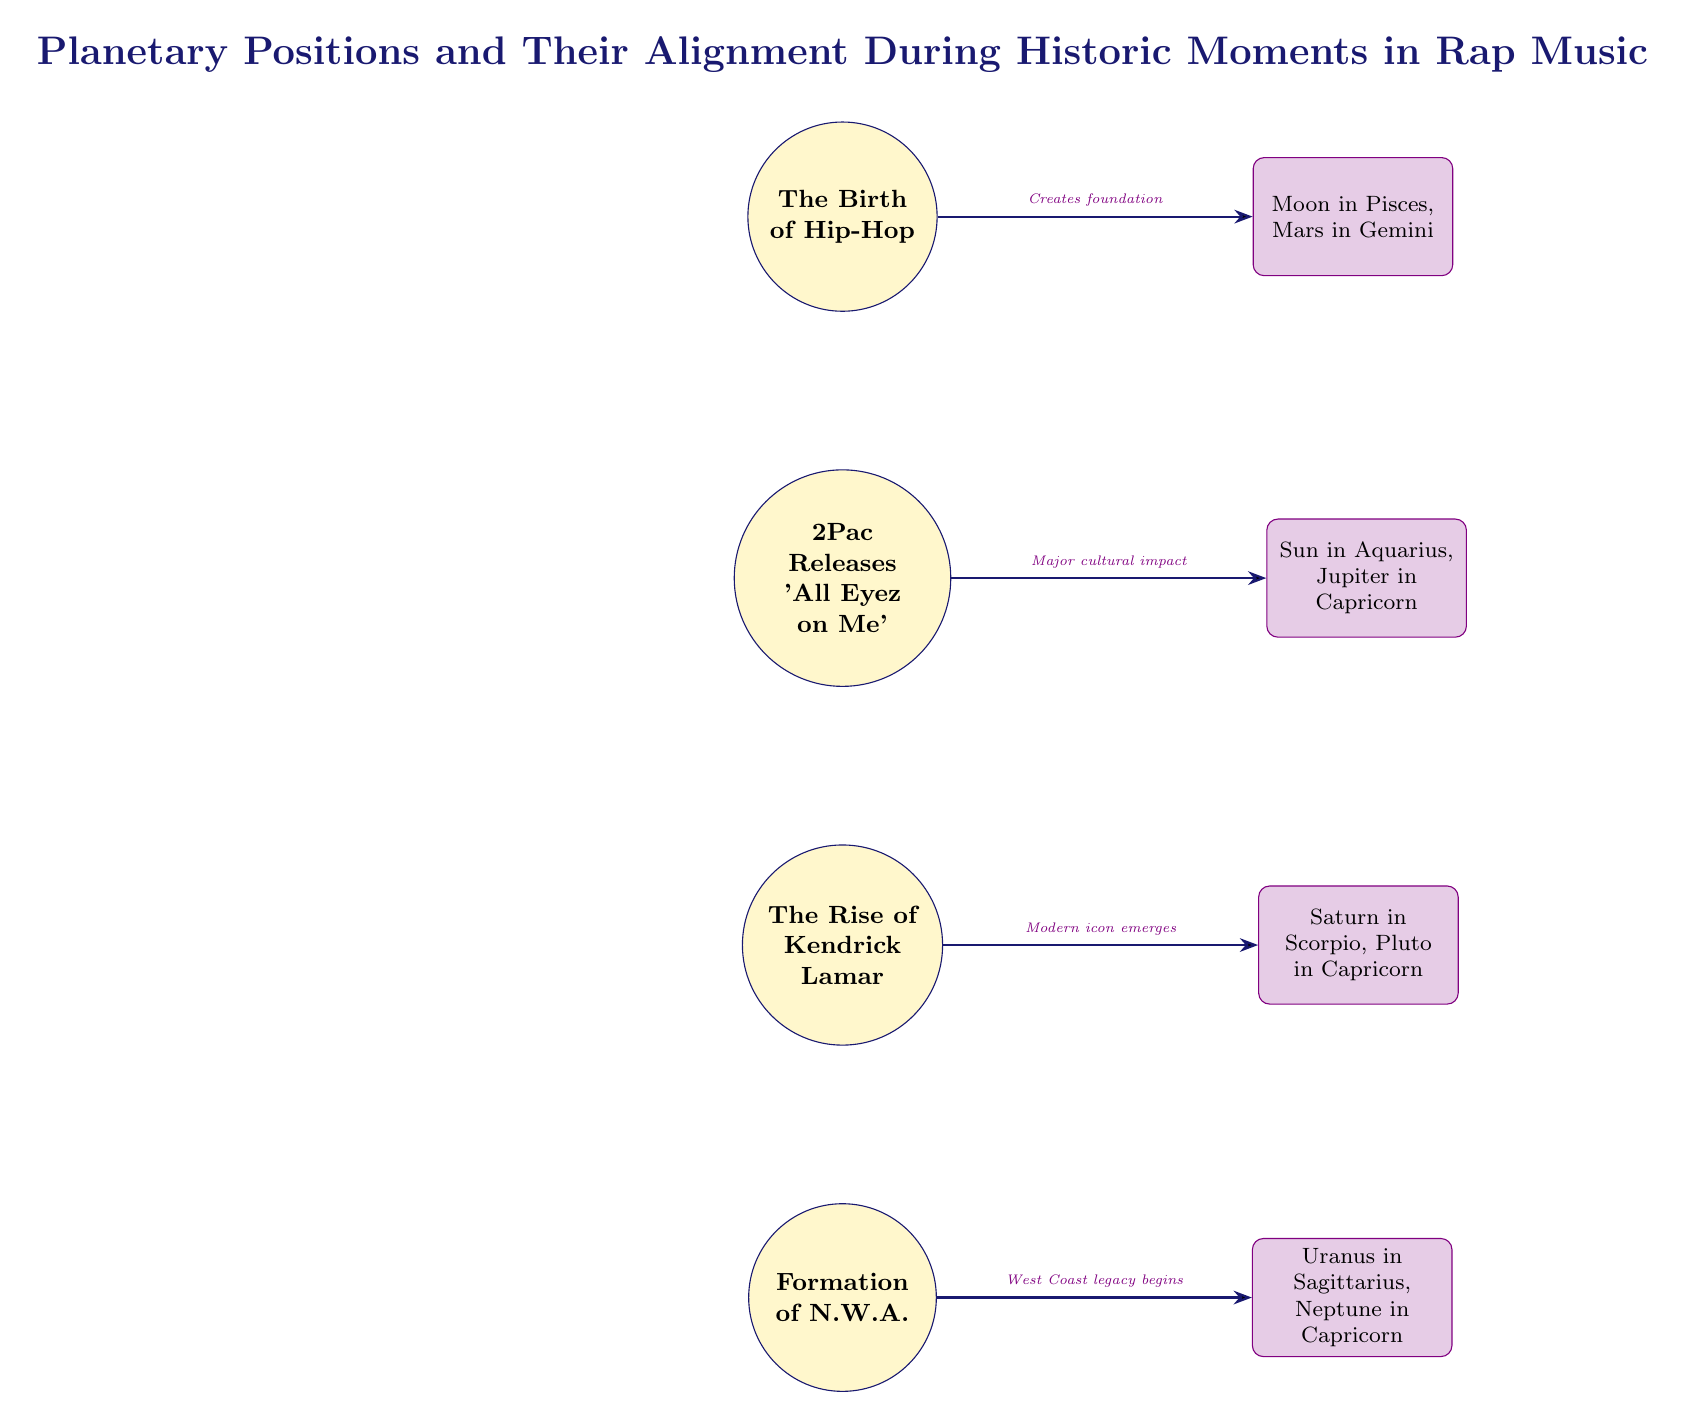What event is represented at the top of the diagram? The node at the top of the diagram corresponds to "The Birth of Hip-Hop," which is the first event listed.
Answer: The Birth of Hip-Hop What planetary alignment is associated with the rise of Kendrick Lamar? The rise of Kendrick Lamar is associated with the planetary alignment of "Saturn in Scorpio, Pluto in Capricorn," which is the node directly to the right of that event.
Answer: Saturn in Scorpio, Pluto in Capricorn How many events are depicted in the diagram? By counting the event nodes labeled in the diagram, there are a total of four events represented.
Answer: 4 What does the connection from "Formation of N.W.A." indicate? The connection from "Formation of N.W.A." indicates a "West Coast legacy begins," which describes the impact associated with that event.
Answer: West Coast legacy begins Which two planets are in alignment during the release of 'All Eyez on Me'? The planets in alignment during the release of 'All Eyez on Me' are "Sun in Aquarius, Jupiter in Capricorn," as indicated by the node to the right of that event.
Answer: Sun in Aquarius, Jupiter in Capricorn What is the significance of the alignment during "The Birth of Hip-Hop"? The alignment during "The Birth of Hip-Hop" is "Moon in Pisces, Mars in Gemini," which is linked to the foundation of the hip-hop genre as noted by the connection line.
Answer: Moon in Pisces, Mars in Gemini Which event has no direct planetary alignment noted in the diagram? Among the events listed, all have associated planetary alignments, therefore there are no events without a noted alignment in the diagram.
Answer: None Which event is linked to "Modern icon emerges"? The event linked to "Modern icon emerges" is "The Rise of Kendrick Lamar," since that is the event which has this connection.
Answer: The Rise of Kendrick Lamar What color represents the events in the diagram? The events in the diagram are represented by a color called stargold, which fills the event nodes.
Answer: stargold 